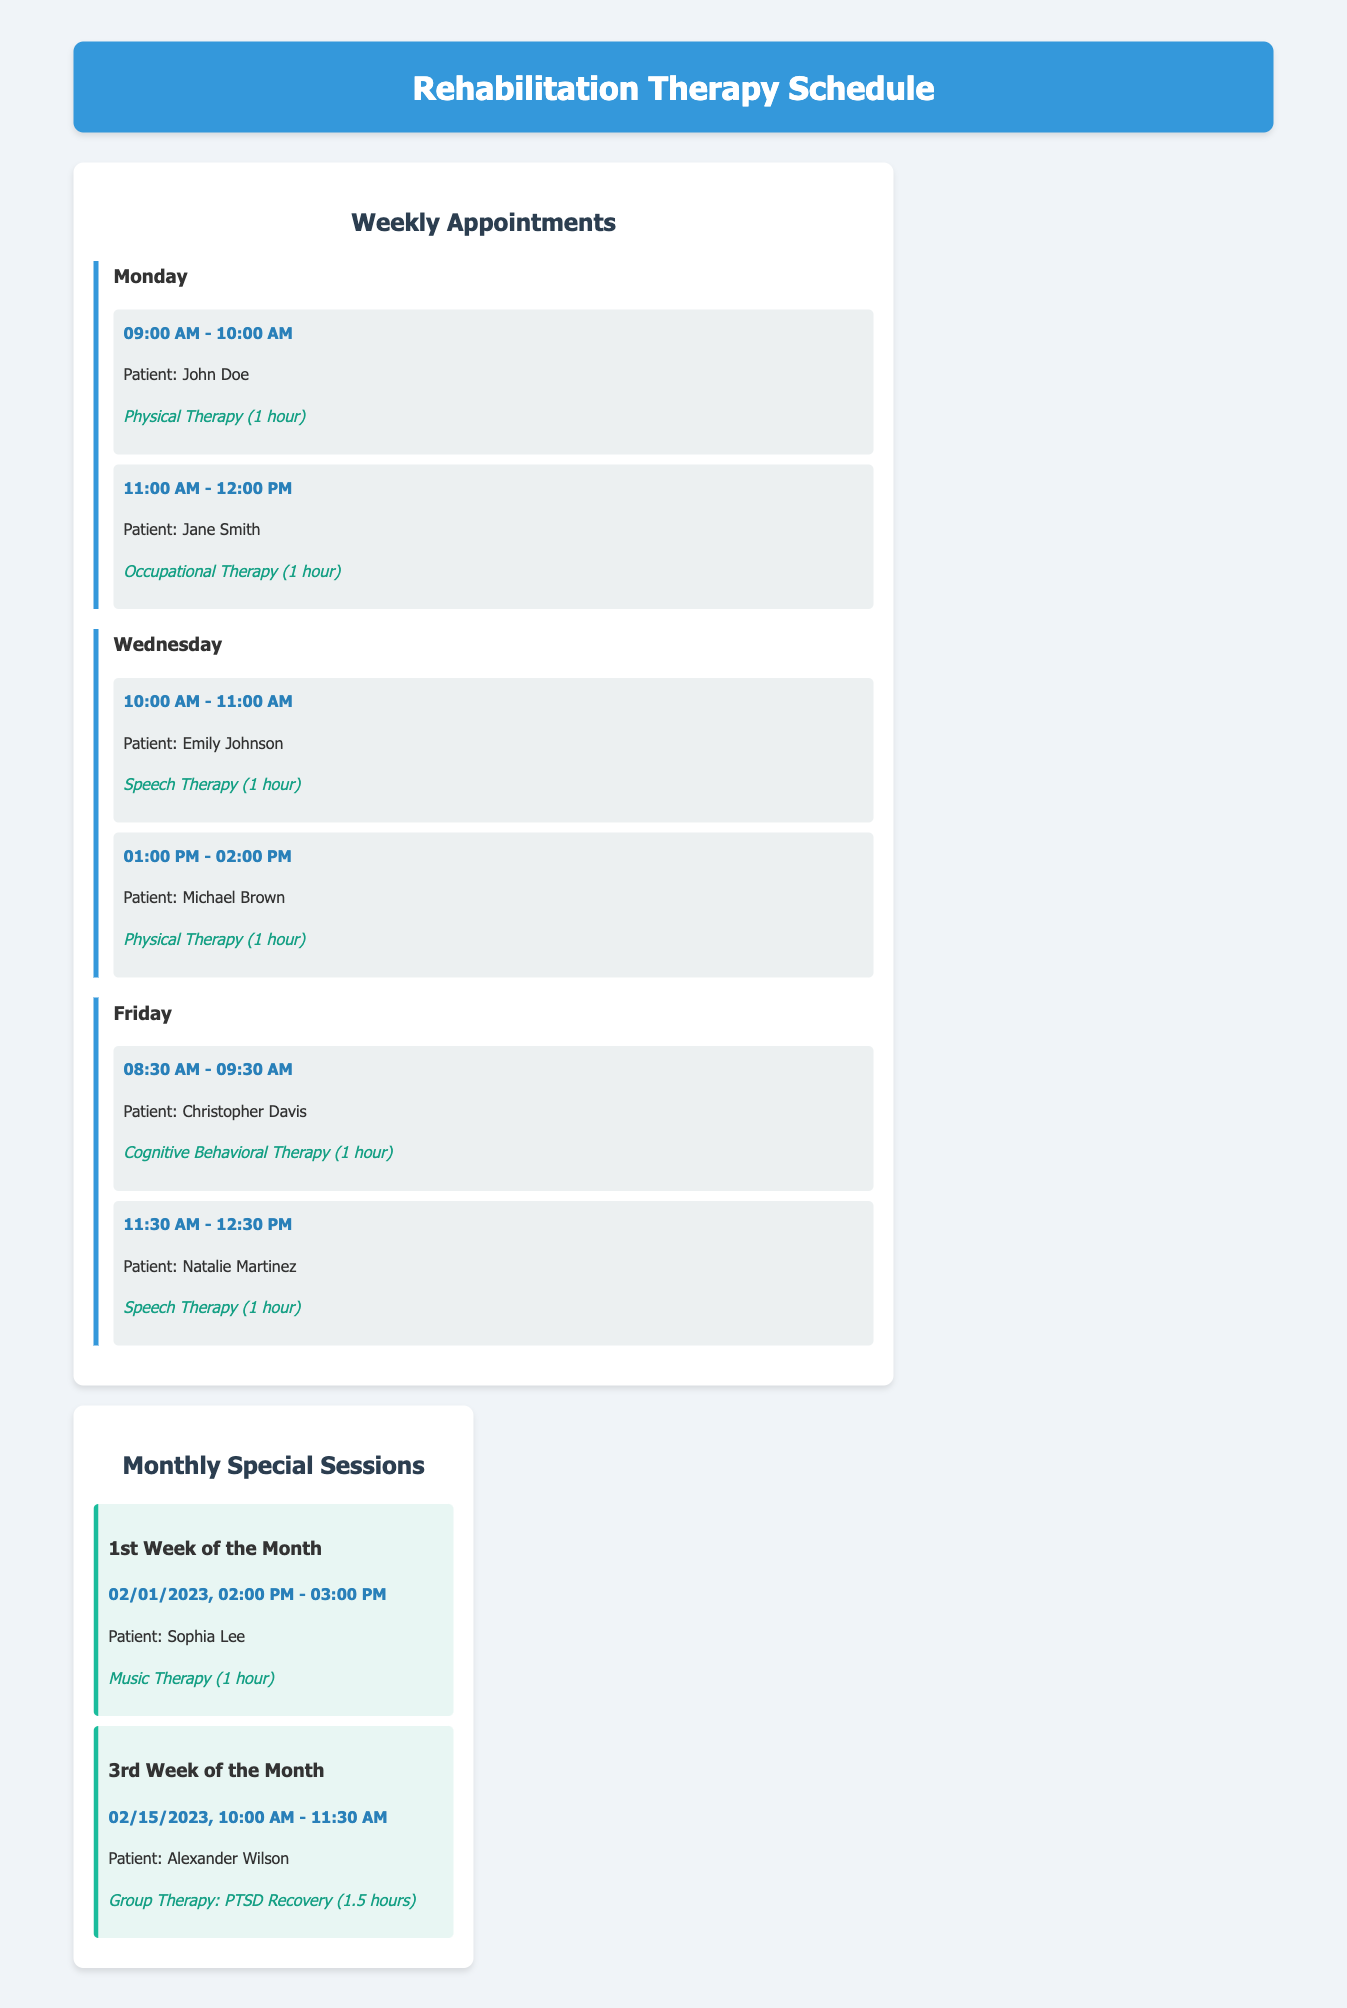what is the first patient's name on Monday? The first session on Monday lists John Doe as the patient.
Answer: John Doe how long is each therapy session? Each therapy session listed in the document has a duration of one hour, except for the group therapy session, which lasts one and a half hours.
Answer: 1 hour which therapy type is scheduled for Emily Johnson? The session for Emily Johnson specifies the therapy type as Speech Therapy.
Answer: Speech Therapy when is the music therapy session scheduled? The document states that the music therapy session is scheduled for the 1st week of the month on February 1, 2023.
Answer: 02/01/2023 how many therapy sessions are scheduled on Friday? There are two therapy sessions scheduled on Friday, one for cognitive behavioral therapy and one for speech therapy.
Answer: 2 what is the time for Michael Brown's physical therapy session? Michael Brown's physical therapy session is scheduled from 1:00 PM to 2:00 PM on Wednesday.
Answer: 01:00 PM - 02:00 PM which day has an occupational therapy session? The occupational therapy session is scheduled on Monday for Jane Smith.
Answer: Monday who is scheduled for group therapy in the third week of the month? The document lists Alexander Wilson as the patient scheduled for group therapy in the third week.
Answer: Alexander Wilson 